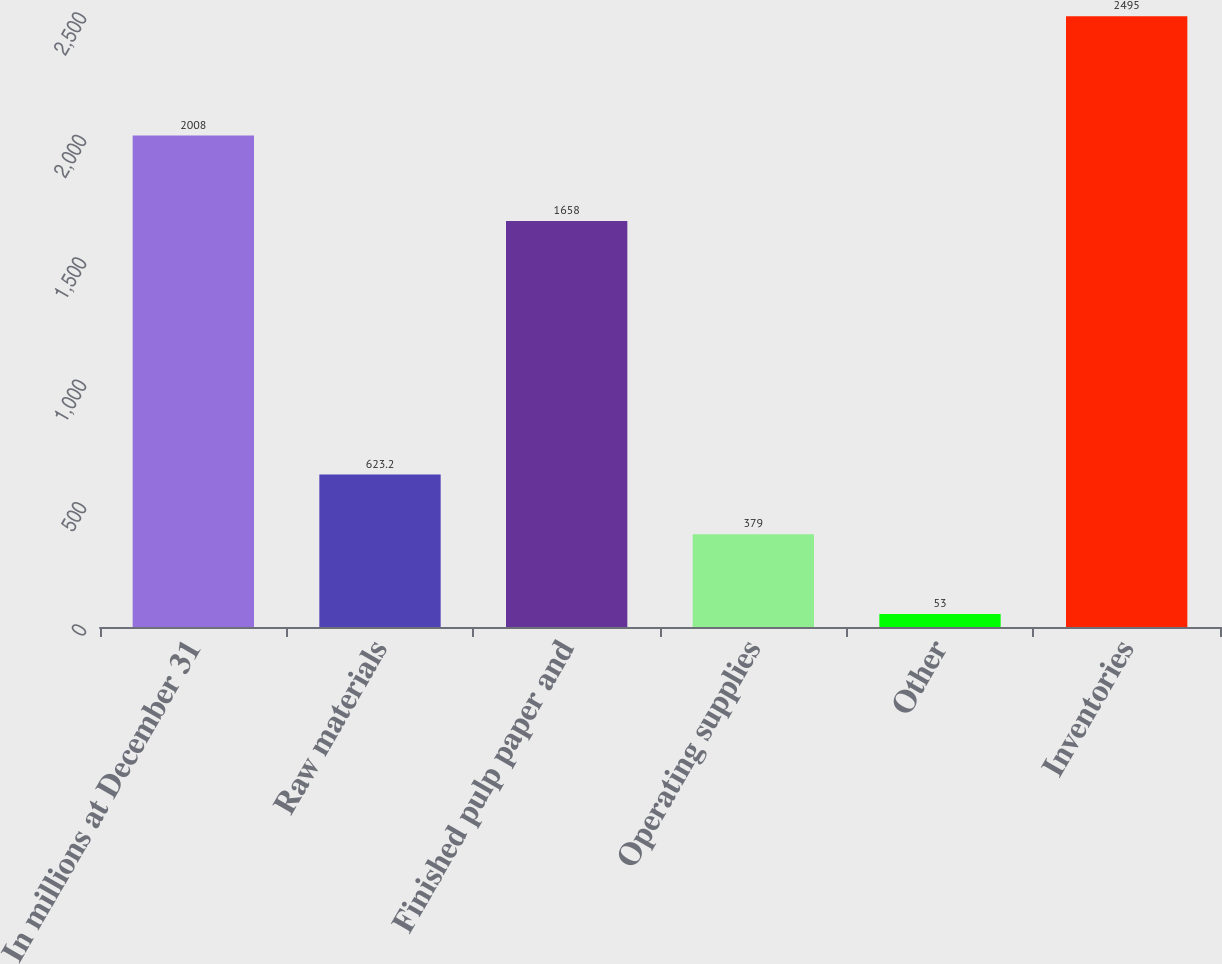<chart> <loc_0><loc_0><loc_500><loc_500><bar_chart><fcel>In millions at December 31<fcel>Raw materials<fcel>Finished pulp paper and<fcel>Operating supplies<fcel>Other<fcel>Inventories<nl><fcel>2008<fcel>623.2<fcel>1658<fcel>379<fcel>53<fcel>2495<nl></chart> 